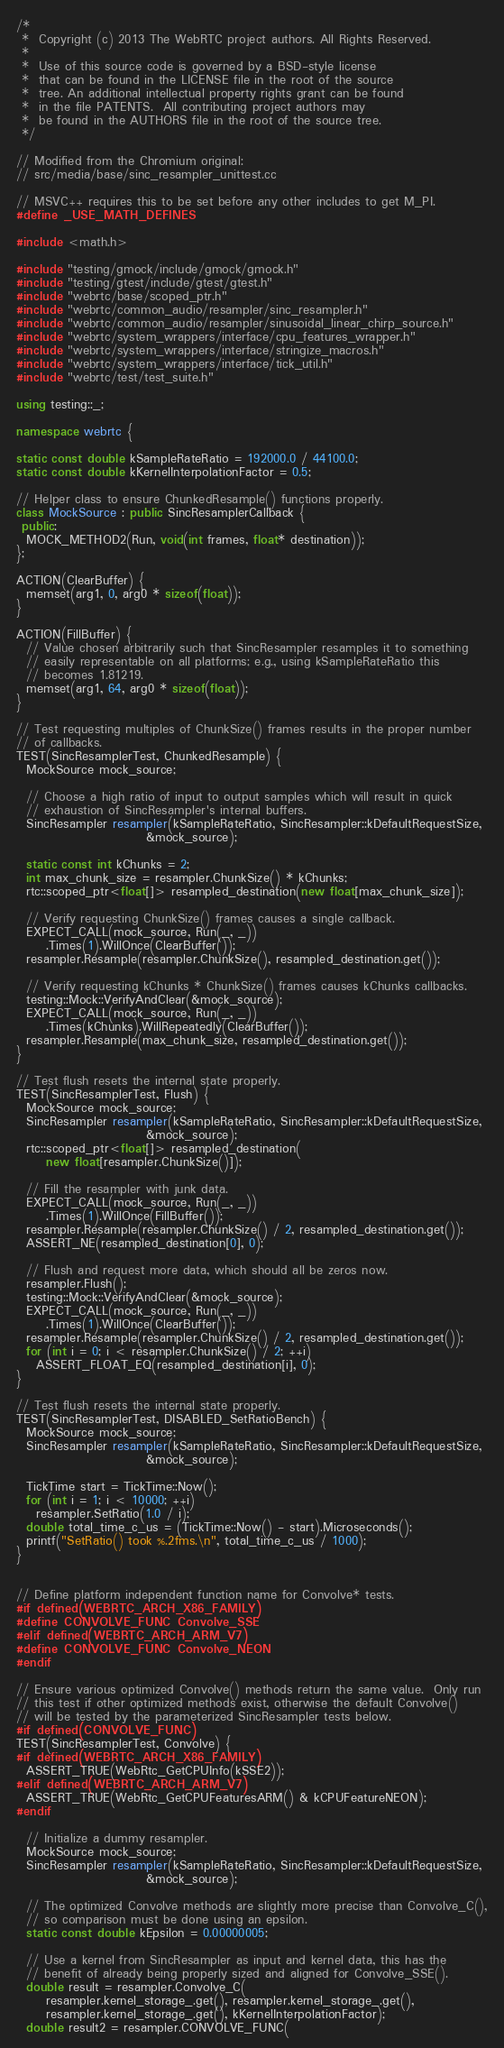<code> <loc_0><loc_0><loc_500><loc_500><_C++_>/*
 *  Copyright (c) 2013 The WebRTC project authors. All Rights Reserved.
 *
 *  Use of this source code is governed by a BSD-style license
 *  that can be found in the LICENSE file in the root of the source
 *  tree. An additional intellectual property rights grant can be found
 *  in the file PATENTS.  All contributing project authors may
 *  be found in the AUTHORS file in the root of the source tree.
 */

// Modified from the Chromium original:
// src/media/base/sinc_resampler_unittest.cc

// MSVC++ requires this to be set before any other includes to get M_PI.
#define _USE_MATH_DEFINES

#include <math.h>

#include "testing/gmock/include/gmock/gmock.h"
#include "testing/gtest/include/gtest/gtest.h"
#include "webrtc/base/scoped_ptr.h"
#include "webrtc/common_audio/resampler/sinc_resampler.h"
#include "webrtc/common_audio/resampler/sinusoidal_linear_chirp_source.h"
#include "webrtc/system_wrappers/interface/cpu_features_wrapper.h"
#include "webrtc/system_wrappers/interface/stringize_macros.h"
#include "webrtc/system_wrappers/interface/tick_util.h"
#include "webrtc/test/test_suite.h"

using testing::_;

namespace webrtc {

static const double kSampleRateRatio = 192000.0 / 44100.0;
static const double kKernelInterpolationFactor = 0.5;

// Helper class to ensure ChunkedResample() functions properly.
class MockSource : public SincResamplerCallback {
 public:
  MOCK_METHOD2(Run, void(int frames, float* destination));
};

ACTION(ClearBuffer) {
  memset(arg1, 0, arg0 * sizeof(float));
}

ACTION(FillBuffer) {
  // Value chosen arbitrarily such that SincResampler resamples it to something
  // easily representable on all platforms; e.g., using kSampleRateRatio this
  // becomes 1.81219.
  memset(arg1, 64, arg0 * sizeof(float));
}

// Test requesting multiples of ChunkSize() frames results in the proper number
// of callbacks.
TEST(SincResamplerTest, ChunkedResample) {
  MockSource mock_source;

  // Choose a high ratio of input to output samples which will result in quick
  // exhaustion of SincResampler's internal buffers.
  SincResampler resampler(kSampleRateRatio, SincResampler::kDefaultRequestSize,
                          &mock_source);

  static const int kChunks = 2;
  int max_chunk_size = resampler.ChunkSize() * kChunks;
  rtc::scoped_ptr<float[]> resampled_destination(new float[max_chunk_size]);

  // Verify requesting ChunkSize() frames causes a single callback.
  EXPECT_CALL(mock_source, Run(_, _))
      .Times(1).WillOnce(ClearBuffer());
  resampler.Resample(resampler.ChunkSize(), resampled_destination.get());

  // Verify requesting kChunks * ChunkSize() frames causes kChunks callbacks.
  testing::Mock::VerifyAndClear(&mock_source);
  EXPECT_CALL(mock_source, Run(_, _))
      .Times(kChunks).WillRepeatedly(ClearBuffer());
  resampler.Resample(max_chunk_size, resampled_destination.get());
}

// Test flush resets the internal state properly.
TEST(SincResamplerTest, Flush) {
  MockSource mock_source;
  SincResampler resampler(kSampleRateRatio, SincResampler::kDefaultRequestSize,
                          &mock_source);
  rtc::scoped_ptr<float[]> resampled_destination(
      new float[resampler.ChunkSize()]);

  // Fill the resampler with junk data.
  EXPECT_CALL(mock_source, Run(_, _))
      .Times(1).WillOnce(FillBuffer());
  resampler.Resample(resampler.ChunkSize() / 2, resampled_destination.get());
  ASSERT_NE(resampled_destination[0], 0);

  // Flush and request more data, which should all be zeros now.
  resampler.Flush();
  testing::Mock::VerifyAndClear(&mock_source);
  EXPECT_CALL(mock_source, Run(_, _))
      .Times(1).WillOnce(ClearBuffer());
  resampler.Resample(resampler.ChunkSize() / 2, resampled_destination.get());
  for (int i = 0; i < resampler.ChunkSize() / 2; ++i)
    ASSERT_FLOAT_EQ(resampled_destination[i], 0);
}

// Test flush resets the internal state properly.
TEST(SincResamplerTest, DISABLED_SetRatioBench) {
  MockSource mock_source;
  SincResampler resampler(kSampleRateRatio, SincResampler::kDefaultRequestSize,
                          &mock_source);

  TickTime start = TickTime::Now();
  for (int i = 1; i < 10000; ++i)
    resampler.SetRatio(1.0 / i);
  double total_time_c_us = (TickTime::Now() - start).Microseconds();
  printf("SetRatio() took %.2fms.\n", total_time_c_us / 1000);
}


// Define platform independent function name for Convolve* tests.
#if defined(WEBRTC_ARCH_X86_FAMILY)
#define CONVOLVE_FUNC Convolve_SSE
#elif defined(WEBRTC_ARCH_ARM_V7)
#define CONVOLVE_FUNC Convolve_NEON
#endif

// Ensure various optimized Convolve() methods return the same value.  Only run
// this test if other optimized methods exist, otherwise the default Convolve()
// will be tested by the parameterized SincResampler tests below.
#if defined(CONVOLVE_FUNC)
TEST(SincResamplerTest, Convolve) {
#if defined(WEBRTC_ARCH_X86_FAMILY)
  ASSERT_TRUE(WebRtc_GetCPUInfo(kSSE2));
#elif defined(WEBRTC_ARCH_ARM_V7)
  ASSERT_TRUE(WebRtc_GetCPUFeaturesARM() & kCPUFeatureNEON);
#endif

  // Initialize a dummy resampler.
  MockSource mock_source;
  SincResampler resampler(kSampleRateRatio, SincResampler::kDefaultRequestSize,
                          &mock_source);

  // The optimized Convolve methods are slightly more precise than Convolve_C(),
  // so comparison must be done using an epsilon.
  static const double kEpsilon = 0.00000005;

  // Use a kernel from SincResampler as input and kernel data, this has the
  // benefit of already being properly sized and aligned for Convolve_SSE().
  double result = resampler.Convolve_C(
      resampler.kernel_storage_.get(), resampler.kernel_storage_.get(),
      resampler.kernel_storage_.get(), kKernelInterpolationFactor);
  double result2 = resampler.CONVOLVE_FUNC(</code> 